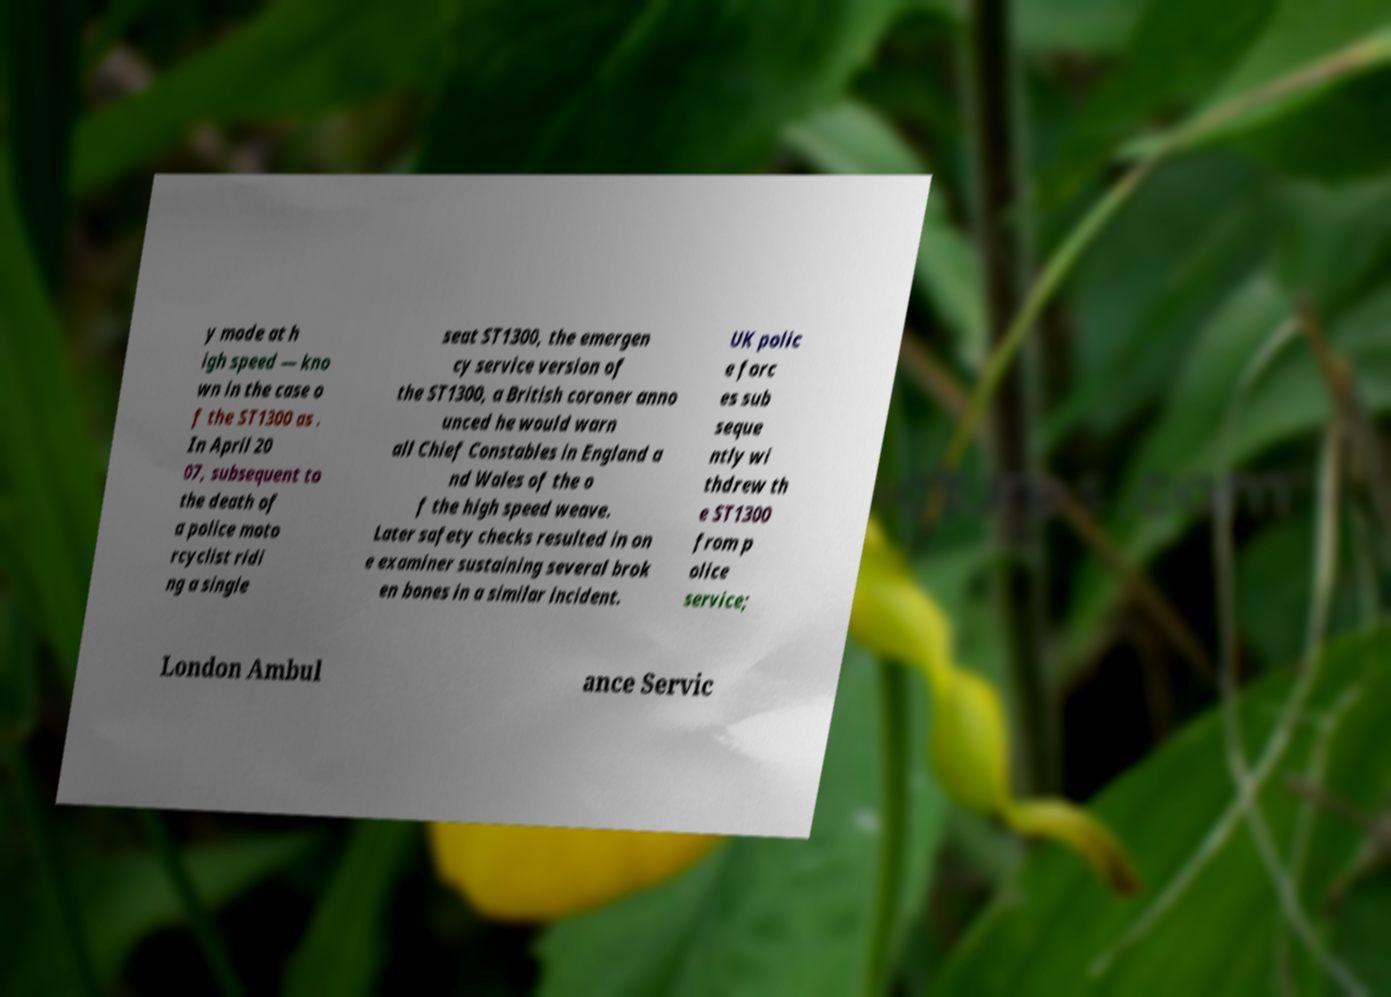Please identify and transcribe the text found in this image. y mode at h igh speed — kno wn in the case o f the ST1300 as . In April 20 07, subsequent to the death of a police moto rcyclist ridi ng a single seat ST1300, the emergen cy service version of the ST1300, a British coroner anno unced he would warn all Chief Constables in England a nd Wales of the o f the high speed weave. Later safety checks resulted in on e examiner sustaining several brok en bones in a similar incident. UK polic e forc es sub seque ntly wi thdrew th e ST1300 from p olice service; London Ambul ance Servic 